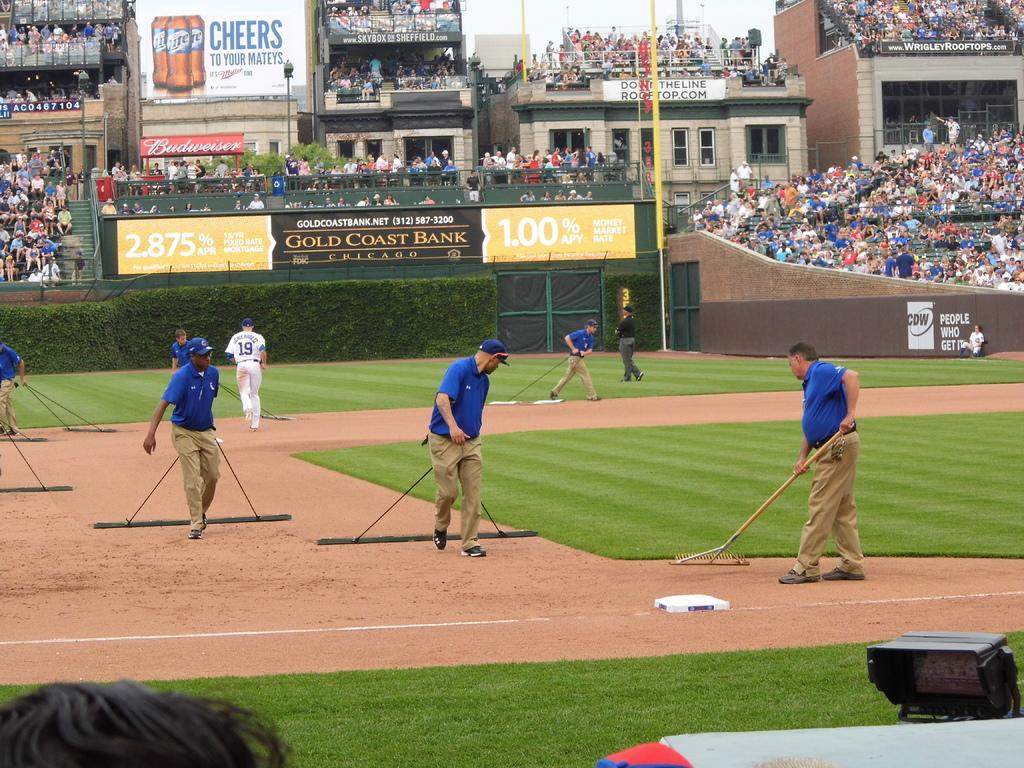<image>
Write a terse but informative summary of the picture. Baseball stadium with a black sign that says Gold Coast Bank. 